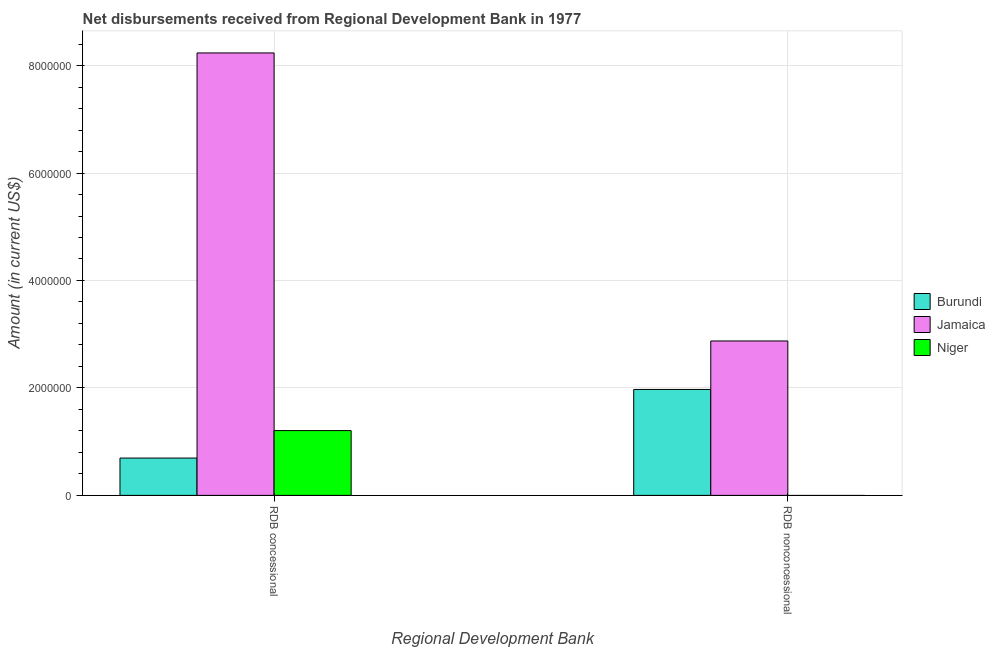How many different coloured bars are there?
Offer a terse response. 3. How many groups of bars are there?
Make the answer very short. 2. Are the number of bars per tick equal to the number of legend labels?
Ensure brevity in your answer.  No. Are the number of bars on each tick of the X-axis equal?
Your answer should be very brief. No. What is the label of the 2nd group of bars from the left?
Keep it short and to the point. RDB nonconcessional. What is the net non concessional disbursements from rdb in Burundi?
Make the answer very short. 1.97e+06. Across all countries, what is the maximum net concessional disbursements from rdb?
Provide a short and direct response. 8.24e+06. Across all countries, what is the minimum net concessional disbursements from rdb?
Your answer should be very brief. 6.95e+05. In which country was the net concessional disbursements from rdb maximum?
Provide a succinct answer. Jamaica. What is the total net non concessional disbursements from rdb in the graph?
Keep it short and to the point. 4.85e+06. What is the difference between the net concessional disbursements from rdb in Burundi and that in Niger?
Make the answer very short. -5.11e+05. What is the difference between the net non concessional disbursements from rdb in Burundi and the net concessional disbursements from rdb in Niger?
Offer a very short reply. 7.66e+05. What is the average net non concessional disbursements from rdb per country?
Make the answer very short. 1.62e+06. What is the difference between the net concessional disbursements from rdb and net non concessional disbursements from rdb in Jamaica?
Your answer should be very brief. 5.36e+06. In how many countries, is the net non concessional disbursements from rdb greater than 5200000 US$?
Provide a succinct answer. 0. What is the ratio of the net concessional disbursements from rdb in Burundi to that in Jamaica?
Give a very brief answer. 0.08. Is the net concessional disbursements from rdb in Niger less than that in Burundi?
Keep it short and to the point. No. How many bars are there?
Provide a succinct answer. 5. Are all the bars in the graph horizontal?
Provide a short and direct response. No. How many countries are there in the graph?
Give a very brief answer. 3. What is the difference between two consecutive major ticks on the Y-axis?
Provide a succinct answer. 2.00e+06. Does the graph contain any zero values?
Offer a very short reply. Yes. Where does the legend appear in the graph?
Provide a succinct answer. Center right. What is the title of the graph?
Give a very brief answer. Net disbursements received from Regional Development Bank in 1977. Does "Poland" appear as one of the legend labels in the graph?
Your answer should be compact. No. What is the label or title of the X-axis?
Offer a very short reply. Regional Development Bank. What is the label or title of the Y-axis?
Offer a terse response. Amount (in current US$). What is the Amount (in current US$) of Burundi in RDB concessional?
Make the answer very short. 6.95e+05. What is the Amount (in current US$) in Jamaica in RDB concessional?
Offer a terse response. 8.24e+06. What is the Amount (in current US$) in Niger in RDB concessional?
Offer a very short reply. 1.21e+06. What is the Amount (in current US$) of Burundi in RDB nonconcessional?
Offer a very short reply. 1.97e+06. What is the Amount (in current US$) of Jamaica in RDB nonconcessional?
Provide a succinct answer. 2.87e+06. What is the Amount (in current US$) of Niger in RDB nonconcessional?
Ensure brevity in your answer.  0. Across all Regional Development Bank, what is the maximum Amount (in current US$) of Burundi?
Keep it short and to the point. 1.97e+06. Across all Regional Development Bank, what is the maximum Amount (in current US$) of Jamaica?
Your answer should be compact. 8.24e+06. Across all Regional Development Bank, what is the maximum Amount (in current US$) of Niger?
Ensure brevity in your answer.  1.21e+06. Across all Regional Development Bank, what is the minimum Amount (in current US$) in Burundi?
Your answer should be very brief. 6.95e+05. Across all Regional Development Bank, what is the minimum Amount (in current US$) of Jamaica?
Your response must be concise. 2.87e+06. Across all Regional Development Bank, what is the minimum Amount (in current US$) of Niger?
Your answer should be very brief. 0. What is the total Amount (in current US$) of Burundi in the graph?
Provide a succinct answer. 2.67e+06. What is the total Amount (in current US$) in Jamaica in the graph?
Your answer should be compact. 1.11e+07. What is the total Amount (in current US$) in Niger in the graph?
Give a very brief answer. 1.21e+06. What is the difference between the Amount (in current US$) in Burundi in RDB concessional and that in RDB nonconcessional?
Provide a succinct answer. -1.28e+06. What is the difference between the Amount (in current US$) of Jamaica in RDB concessional and that in RDB nonconcessional?
Provide a short and direct response. 5.36e+06. What is the difference between the Amount (in current US$) in Burundi in RDB concessional and the Amount (in current US$) in Jamaica in RDB nonconcessional?
Ensure brevity in your answer.  -2.18e+06. What is the average Amount (in current US$) in Burundi per Regional Development Bank?
Offer a very short reply. 1.33e+06. What is the average Amount (in current US$) of Jamaica per Regional Development Bank?
Provide a short and direct response. 5.55e+06. What is the average Amount (in current US$) in Niger per Regional Development Bank?
Offer a terse response. 6.03e+05. What is the difference between the Amount (in current US$) of Burundi and Amount (in current US$) of Jamaica in RDB concessional?
Your answer should be very brief. -7.54e+06. What is the difference between the Amount (in current US$) in Burundi and Amount (in current US$) in Niger in RDB concessional?
Keep it short and to the point. -5.11e+05. What is the difference between the Amount (in current US$) of Jamaica and Amount (in current US$) of Niger in RDB concessional?
Make the answer very short. 7.03e+06. What is the difference between the Amount (in current US$) in Burundi and Amount (in current US$) in Jamaica in RDB nonconcessional?
Your response must be concise. -9.02e+05. What is the ratio of the Amount (in current US$) of Burundi in RDB concessional to that in RDB nonconcessional?
Give a very brief answer. 0.35. What is the ratio of the Amount (in current US$) of Jamaica in RDB concessional to that in RDB nonconcessional?
Your answer should be very brief. 2.87. What is the difference between the highest and the second highest Amount (in current US$) in Burundi?
Your answer should be compact. 1.28e+06. What is the difference between the highest and the second highest Amount (in current US$) in Jamaica?
Provide a succinct answer. 5.36e+06. What is the difference between the highest and the lowest Amount (in current US$) of Burundi?
Provide a succinct answer. 1.28e+06. What is the difference between the highest and the lowest Amount (in current US$) in Jamaica?
Your response must be concise. 5.36e+06. What is the difference between the highest and the lowest Amount (in current US$) in Niger?
Keep it short and to the point. 1.21e+06. 